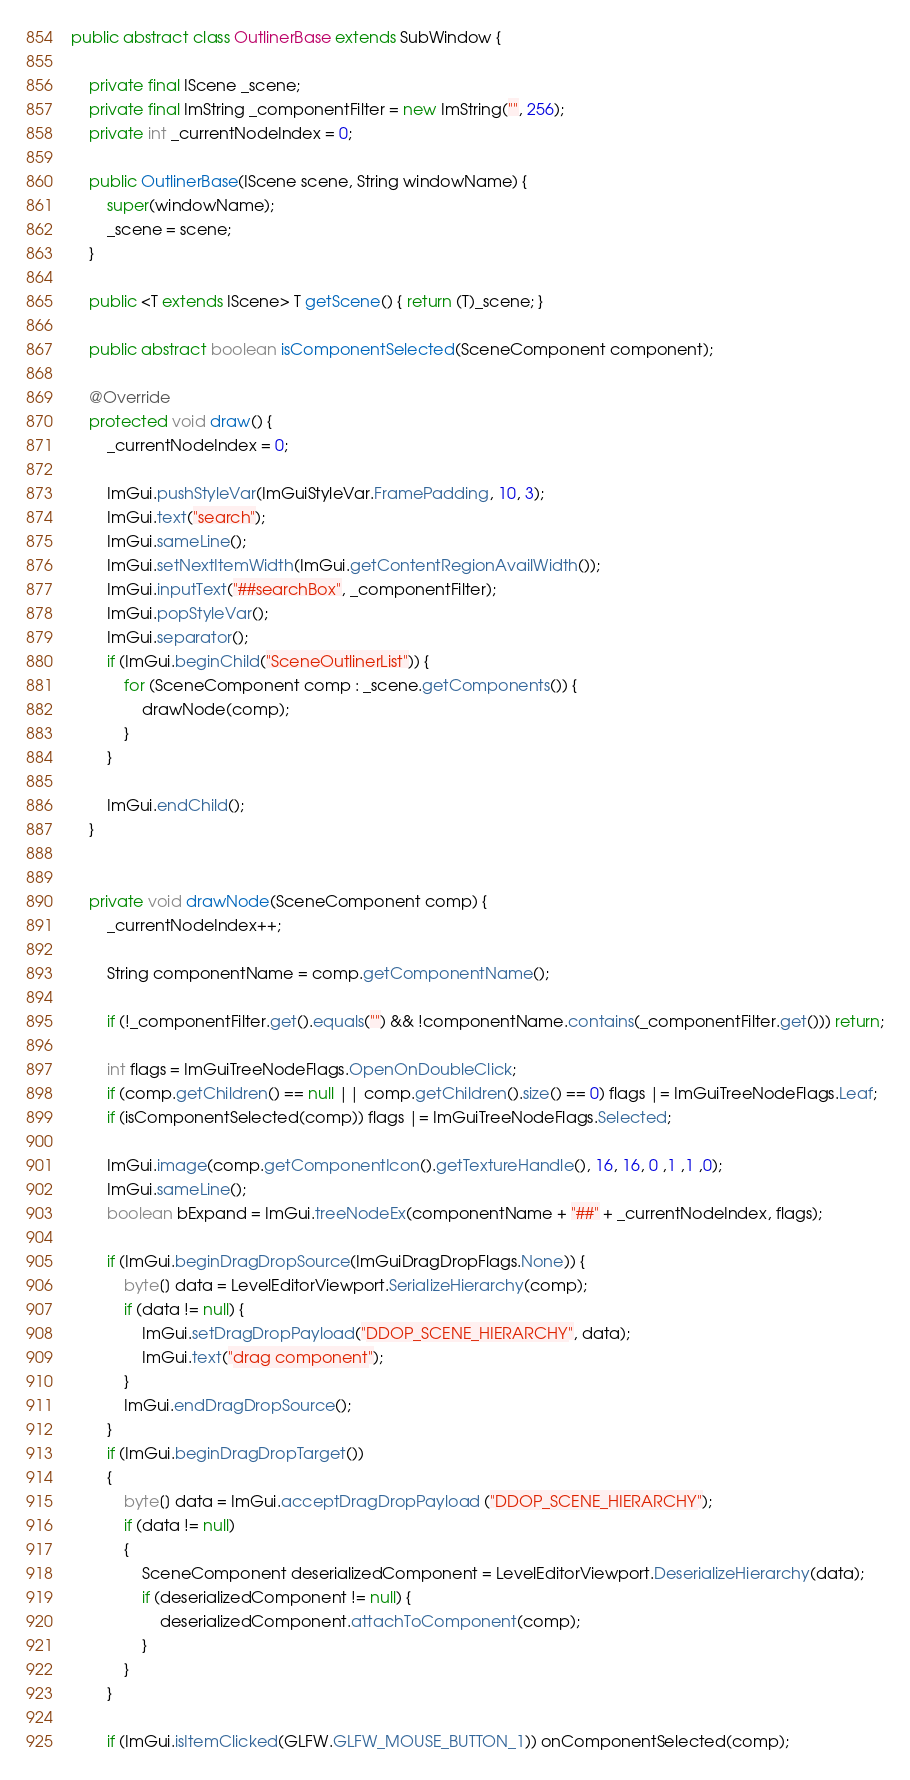<code> <loc_0><loc_0><loc_500><loc_500><_Java_>public abstract class OutlinerBase extends SubWindow {

    private final IScene _scene;
    private final ImString _componentFilter = new ImString("", 256);
    private int _currentNodeIndex = 0;

    public OutlinerBase(IScene scene, String windowName) {
        super(windowName);
        _scene = scene;
    }

    public <T extends IScene> T getScene() { return (T)_scene; }

    public abstract boolean isComponentSelected(SceneComponent component);

    @Override
    protected void draw() {
        _currentNodeIndex = 0;

        ImGui.pushStyleVar(ImGuiStyleVar.FramePadding, 10, 3);
        ImGui.text("search");
        ImGui.sameLine();
        ImGui.setNextItemWidth(ImGui.getContentRegionAvailWidth());
        ImGui.inputText("##searchBox", _componentFilter);
        ImGui.popStyleVar();
        ImGui.separator();
        if (ImGui.beginChild("SceneOutlinerList")) {
            for (SceneComponent comp : _scene.getComponents()) {
                drawNode(comp);
            }
        }

        ImGui.endChild();
    }


    private void drawNode(SceneComponent comp) {
        _currentNodeIndex++;

        String componentName = comp.getComponentName();

        if (!_componentFilter.get().equals("") && !componentName.contains(_componentFilter.get())) return;

        int flags = ImGuiTreeNodeFlags.OpenOnDoubleClick;
        if (comp.getChildren() == null || comp.getChildren().size() == 0) flags |= ImGuiTreeNodeFlags.Leaf;
        if (isComponentSelected(comp)) flags |= ImGuiTreeNodeFlags.Selected;

        ImGui.image(comp.getComponentIcon().getTextureHandle(), 16, 16, 0 ,1 ,1 ,0);
        ImGui.sameLine();
        boolean bExpand = ImGui.treeNodeEx(componentName + "##" + _currentNodeIndex, flags);

        if (ImGui.beginDragDropSource(ImGuiDragDropFlags.None)) {
            byte[] data = LevelEditorViewport.SerializeHierarchy(comp);
            if (data != null) {
                ImGui.setDragDropPayload("DDOP_SCENE_HIERARCHY", data);
                ImGui.text("drag component");
            }
            ImGui.endDragDropSource();
        }
        if (ImGui.beginDragDropTarget())
        {
            byte[] data = ImGui.acceptDragDropPayload ("DDOP_SCENE_HIERARCHY");
            if (data != null)
            {
                SceneComponent deserializedComponent = LevelEditorViewport.DeserializeHierarchy(data);
                if (deserializedComponent != null) {
                    deserializedComponent.attachToComponent(comp);
                }
            }
        }

        if (ImGui.isItemClicked(GLFW.GLFW_MOUSE_BUTTON_1)) onComponentSelected(comp);</code> 